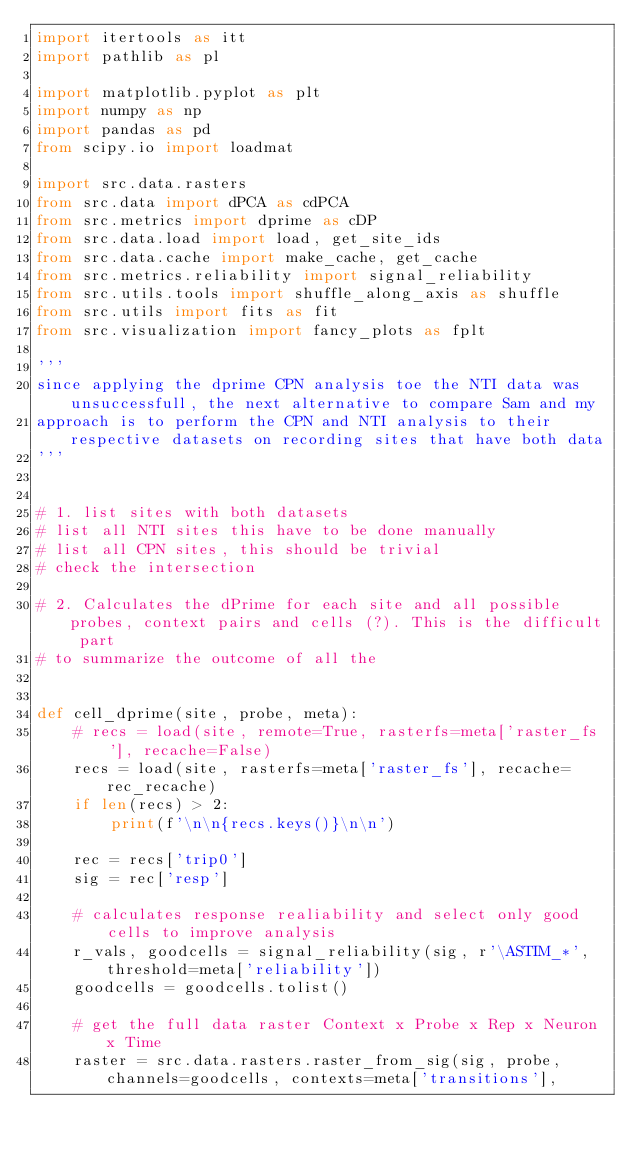Convert code to text. <code><loc_0><loc_0><loc_500><loc_500><_Python_>import itertools as itt
import pathlib as pl

import matplotlib.pyplot as plt
import numpy as np
import pandas as pd
from scipy.io import loadmat

import src.data.rasters
from src.data import dPCA as cdPCA
from src.metrics import dprime as cDP
from src.data.load import load, get_site_ids
from src.data.cache import make_cache, get_cache
from src.metrics.reliability import signal_reliability
from src.utils.tools import shuffle_along_axis as shuffle
from src.utils import fits as fit
from src.visualization import fancy_plots as fplt

'''
since applying the dprime CPN analysis toe the NTI data was unsuccessfull, the next alternative to compare Sam and my
approach is to perform the CPN and NTI analysis to their respective datasets on recording sites that have both data
'''


# 1. list sites with both datasets
# list all NTI sites this have to be done manually
# list all CPN sites, this should be trivial
# check the intersection

# 2. Calculates the dPrime for each site and all possible probes, context pairs and cells (?). This is the difficult part
# to summarize the outcome of all the


def cell_dprime(site, probe, meta):
    # recs = load(site, remote=True, rasterfs=meta['raster_fs'], recache=False)
    recs = load(site, rasterfs=meta['raster_fs'], recache=rec_recache)
    if len(recs) > 2:
        print(f'\n\n{recs.keys()}\n\n')

    rec = recs['trip0']
    sig = rec['resp']

    # calculates response realiability and select only good cells to improve analysis
    r_vals, goodcells = signal_reliability(sig, r'\ASTIM_*', threshold=meta['reliability'])
    goodcells = goodcells.tolist()

    # get the full data raster Context x Probe x Rep x Neuron x Time
    raster = src.data.rasters.raster_from_sig(sig, probe, channels=goodcells, contexts=meta['transitions'],</code> 